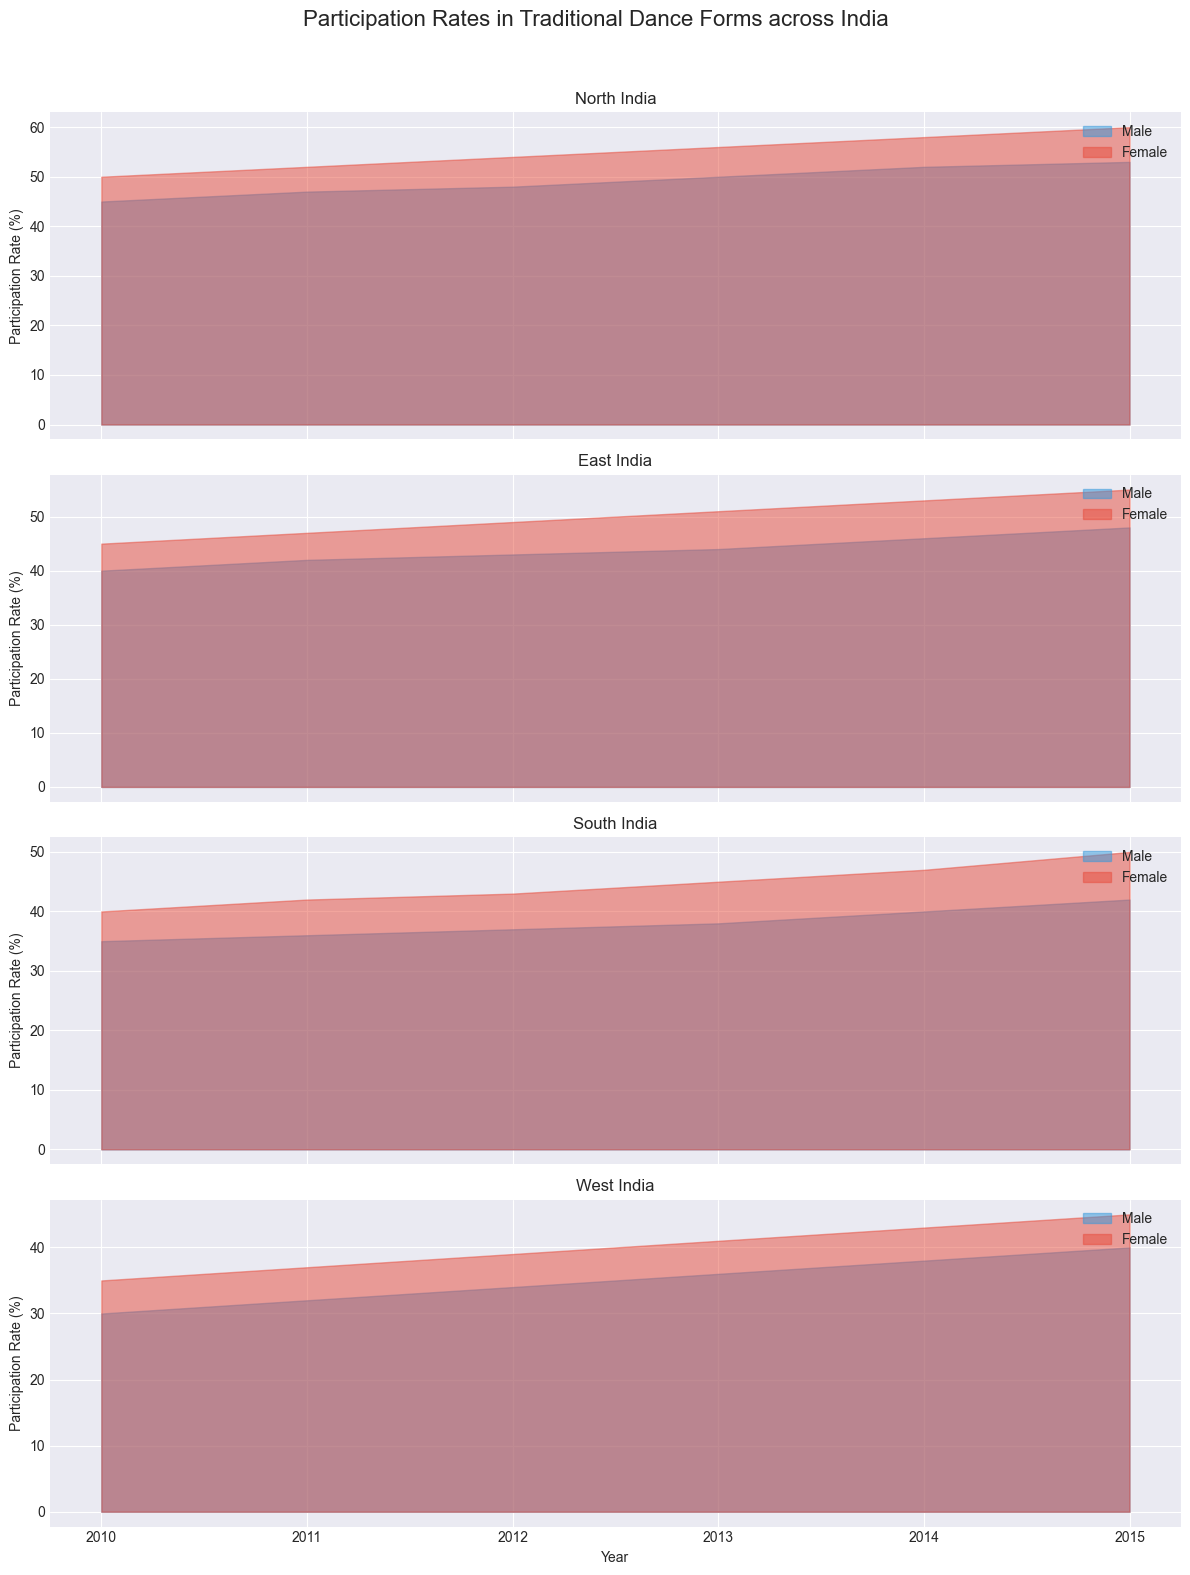What's the participation rate of females in the North region in 2015? Look at the plot for the North region and identify the line or shaded area representing females' participation rate in 2015.
Answer: 60% Between 2010 and 2015, which gender saw a larger increase in participation rate in the South region? Compare the participation rate increase from 2010 to 2015 for both males and females in the South region. Males increased from 35% to 42%, which is 7%. Females increased from 40% to 50%, which is 10%.
Answer: Females What is the average participation rate of males in the East region across all years? Calculate the average by summing the participation rates of males in the East region and dividing by the number of years: (40+42+43+44+46+48)/6 = 43.83%.
Answer: 43.83% In 2013, which region had the highest participation rate for females? Compare the participation rates of females across all regions for the year 2013 and identify the highest value. The rates are North (56%), East (51%), South (45%), West (41%).
Answer: North What is the difference in participation rate between males and females in the West region in 2014? Look at the 2014 participation rates for males (38%) and females (43%) in the West region. Find the difference: 43% - 38% = 5%.
Answer: 5% Which region shows the least variation in female participation rates from 2010 to 2015? Evaluate the range (difference between maximum and minimum values) of female participation rates in each region over the years. North: 60% - 50% =10%, East: 55% - 45% = 10%, South: 50% - 40% = 10%, West: 45% - 35% = 10%.
Answer: All regions have the same variation of 10% Between 2012 and 2013, which region experienced the highest increase in male participation rate? Calculate the increase in male participation rates from 2012 to 2013 across all regions. North: 50% - 48% = 2%, East: 44% - 43% = 1%, South: 38% - 37% = 1%, West: 36% - 34% = 2%.
Answer: North and West What trend is observed in the participation rates for both genders in the North region from 2010 to 2015? Observe the pattern of increase or decrease in the shaded areas for both genders in the North region over the years. Both males and females show a consistent increase in participation rates.
Answer: Increasing trend for both genders Comparing 2010 to 2015, which region had the most consistent growth in male participation rates? Examine the plots and compare the consistency of the growth in participation rates for males in each region from 2010 to 2015. The growth appears most consistent in the North region.
Answer: North 